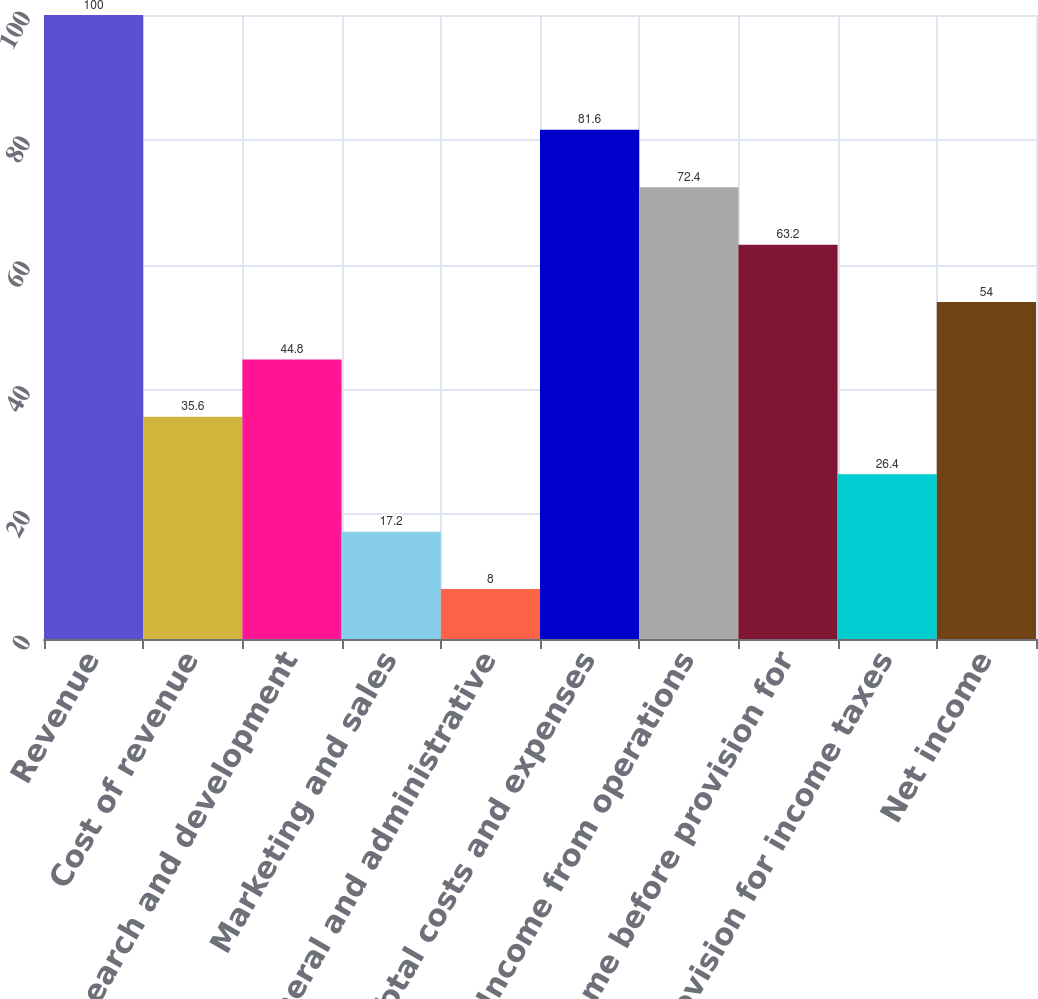Convert chart. <chart><loc_0><loc_0><loc_500><loc_500><bar_chart><fcel>Revenue<fcel>Cost of revenue<fcel>Research and development<fcel>Marketing and sales<fcel>General and administrative<fcel>Total costs and expenses<fcel>Income from operations<fcel>Income before provision for<fcel>Provision for income taxes<fcel>Net income<nl><fcel>100<fcel>35.6<fcel>44.8<fcel>17.2<fcel>8<fcel>81.6<fcel>72.4<fcel>63.2<fcel>26.4<fcel>54<nl></chart> 